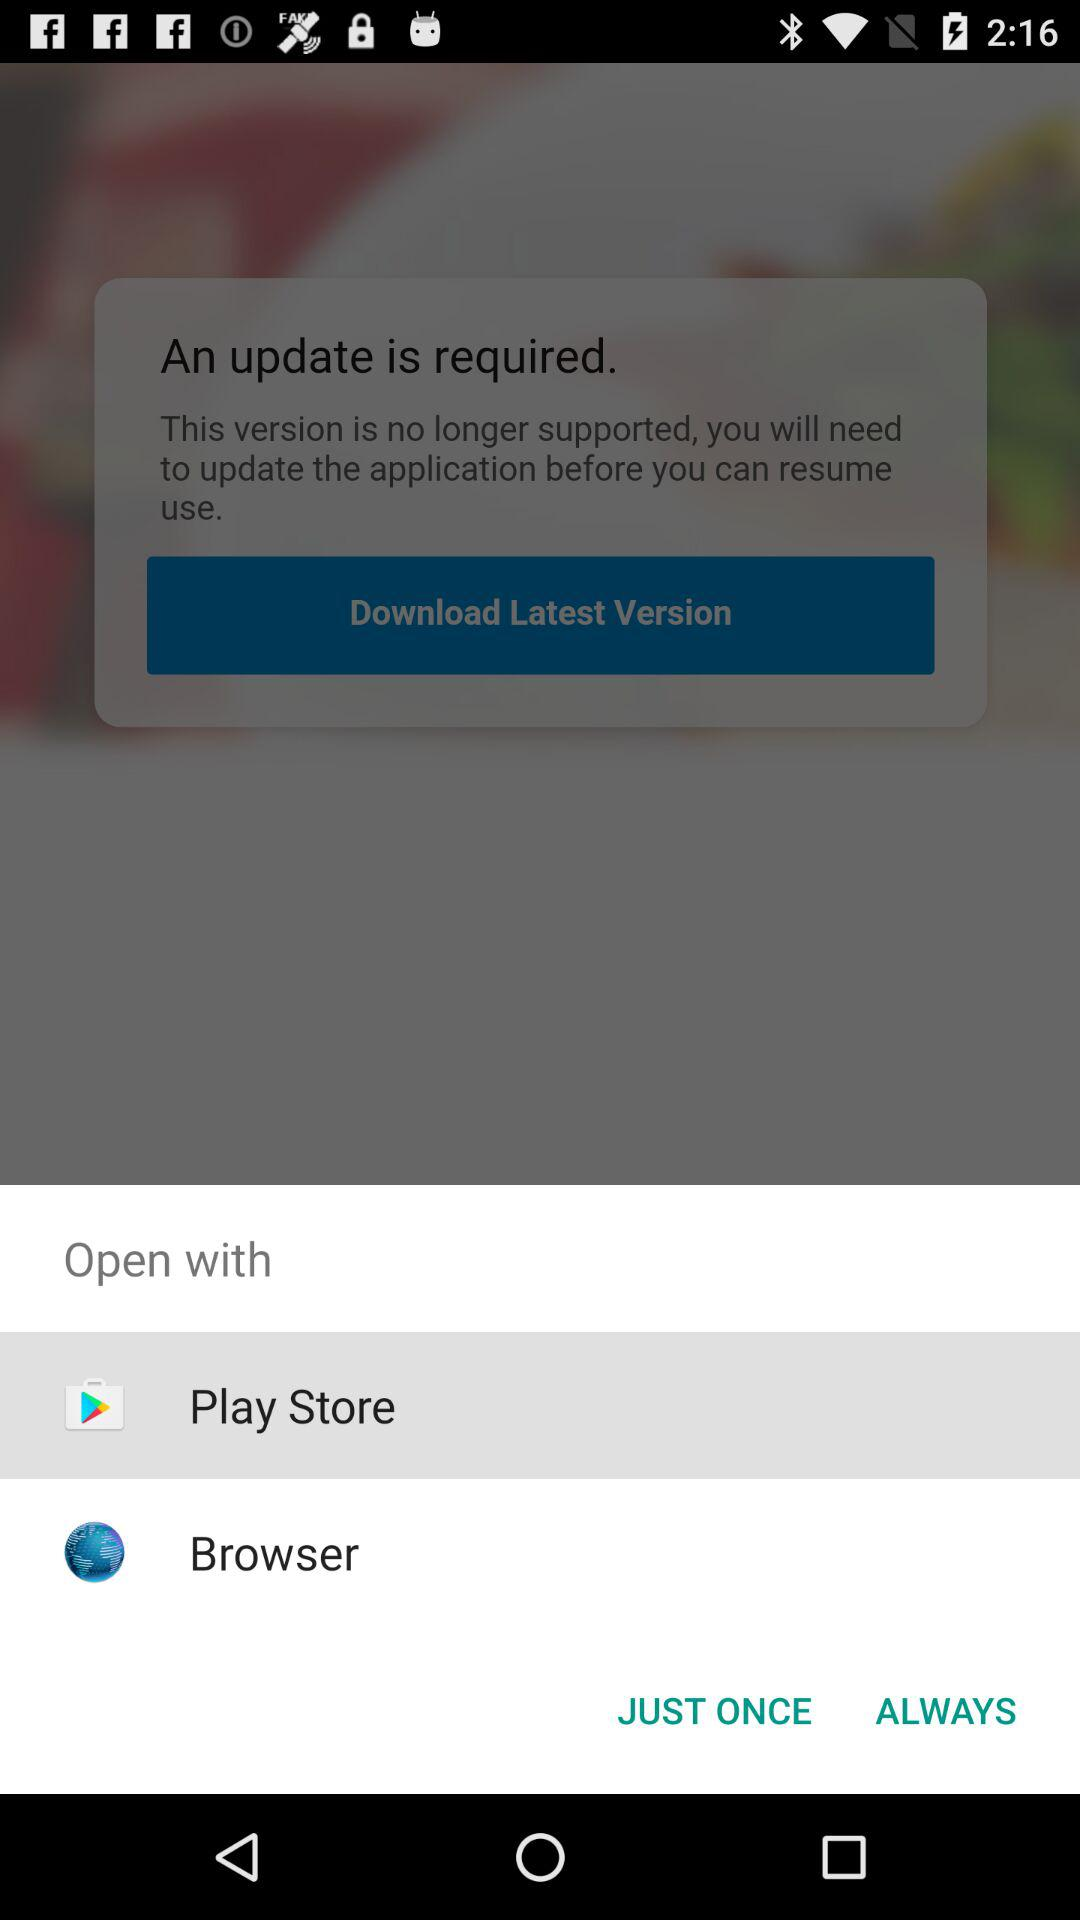What applications can be used to open? The applications that can be used are "Play Store" and "Browser". 